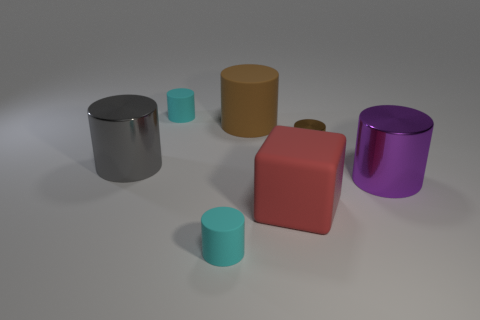What color is the block?
Offer a terse response. Red. Is the shape of the big rubber thing that is behind the large gray metal object the same as  the tiny brown thing?
Ensure brevity in your answer.  Yes. How many objects are small cyan things that are behind the small metallic thing or brown cylinders?
Your answer should be compact. 3. Is there another large purple metal object of the same shape as the purple thing?
Your answer should be very brief. No. There is a brown object that is the same size as the red matte object; what shape is it?
Make the answer very short. Cylinder. There is a matte thing to the right of the big brown rubber cylinder behind the large metallic cylinder that is on the left side of the block; what is its shape?
Offer a very short reply. Cube. There is a big brown object; does it have the same shape as the tiny thing in front of the large red matte cube?
Keep it short and to the point. Yes. What number of tiny things are cyan metal cylinders or cyan cylinders?
Ensure brevity in your answer.  2. Are there any cyan rubber things of the same size as the red matte cube?
Provide a succinct answer. No. What color is the large thing left of the cyan matte thing behind the big matte object that is left of the big red matte cube?
Offer a very short reply. Gray. 